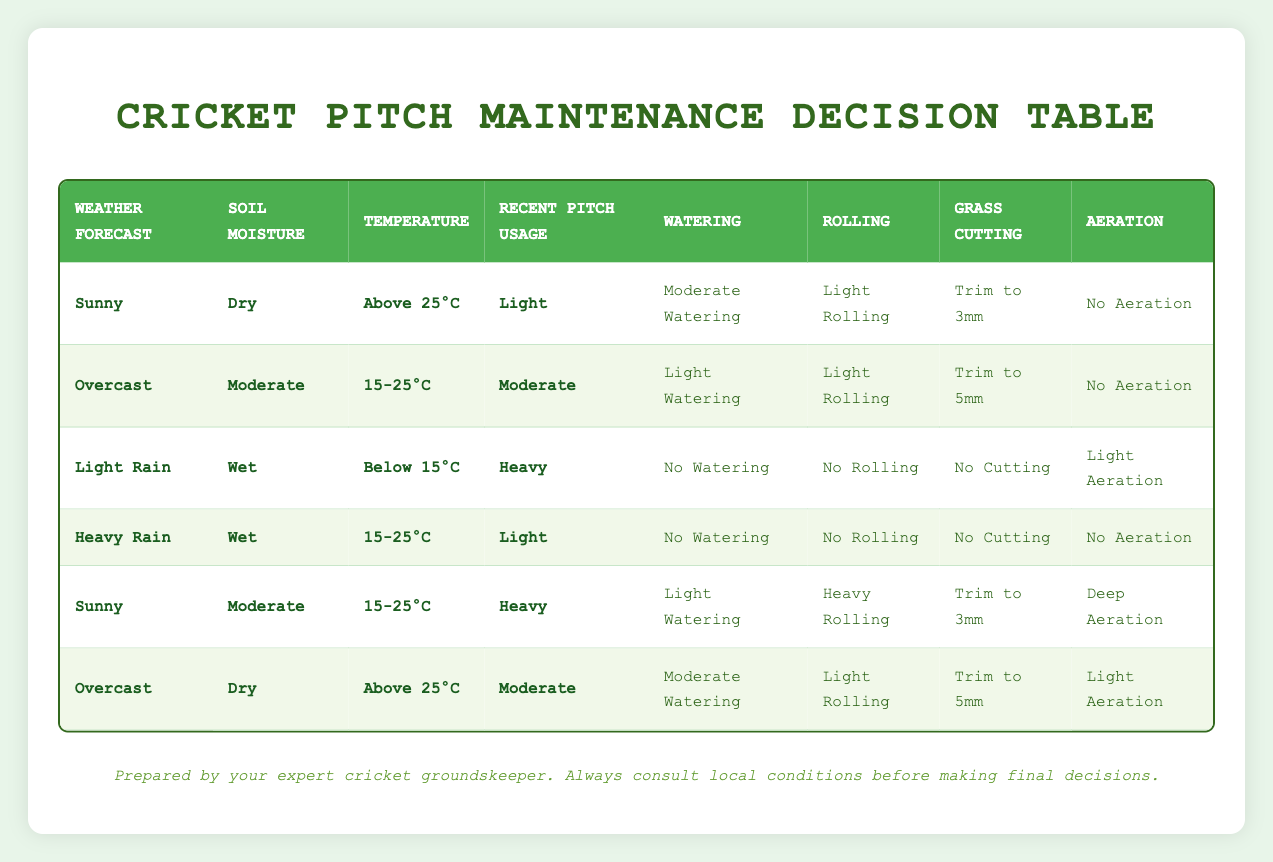What actions are recommended for a sunny day with dry soil, above 25°C and light usage? According to the table, under these specific conditions, the recommended actions are: moderate watering, light rolling, trim to 3mm, and no aeration.
Answer: Moderate watering, light rolling, trim to 3mm, no aeration Is there any aeration suggested during heavy rain when the soil is wet and the recent usage is light? The table indicates that under these conditions (heavy rain, wet soil, light usage), no aeration is performed.
Answer: No What temperature condition corresponds to light watering, light rolling, and trimming to 5mm for an overcast day? Referring to the table, the temperature condition for overcast weather, moderate soil, and moderate usage that leads to light watering, light rolling, and trimming to 5mm is 15-25°C.
Answer: 15-25°C How many different actions are taken when the weather is cloudy, soil moist, temperature between 15-25°C, and usage is light? In this scenario, the actions to take are: no watering, no rolling, no cutting, and no aeration. This results in a total of four actions.
Answer: Four If the recent pitch usage was moderate and the weather was sunny at 15-25°C, what would you do with the grass? The table suggests that on a sunny day, moderate soil, and moderate temperature at 15-25°C with heavy usage, you should trim the grass to 3mm and perform deep aeration.
Answer: Trim to 3mm, deep aeration What is the difference in actions between light rain and heavy rain when the soil is wet and recent usage is heavy? For light rain with wet soil and heavy usage, the actions include no watering and light aeration, while for heavy rain under the same conditions, the actions are no watering and no aeration. Therefore, the difference is that light aeration is performed in the case of light rain but not in heavy rain.
Answer: Light aeration vs no aeration What is the recommended approach for pitch maintenance during light rain, with wet soil, below 15°C, and heavy usage? The table shows that during these conditions (light rain, wet soil, below 15°C, heavy usage), no watering, no rolling, no cutting, and light aeration are recommended.
Answer: No watering, no rolling, no cutting, light aeration In total, how many different watering options are provided for different conditions in the table? A quick look at the actions shows there are four watering options: no watering, light watering, moderate watering, and heavy watering. Thus, there are four different watering options provided.
Answer: Four 